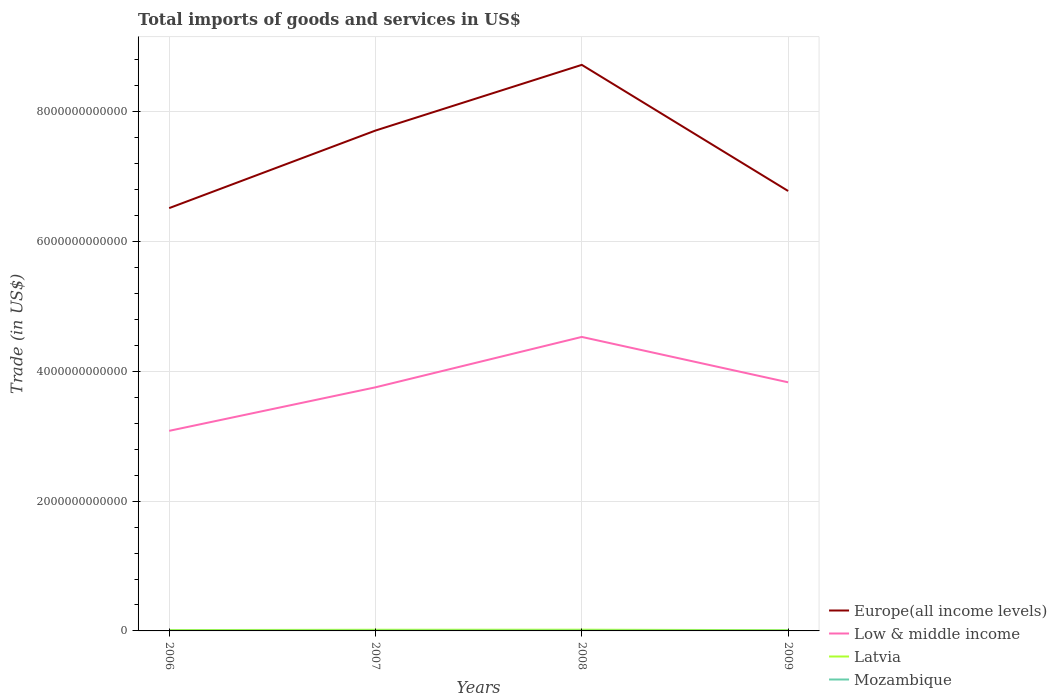How many different coloured lines are there?
Offer a terse response. 4. Does the line corresponding to Low & middle income intersect with the line corresponding to Latvia?
Make the answer very short. No. Across all years, what is the maximum total imports of goods and services in Mozambique?
Offer a very short reply. 3.41e+09. In which year was the total imports of goods and services in Latvia maximum?
Provide a short and direct response. 2009. What is the total total imports of goods and services in Low & middle income in the graph?
Your answer should be compact. -7.48e+11. What is the difference between the highest and the second highest total imports of goods and services in Latvia?
Make the answer very short. 7.10e+09. What is the difference between the highest and the lowest total imports of goods and services in Latvia?
Provide a short and direct response. 2. Is the total imports of goods and services in Mozambique strictly greater than the total imports of goods and services in Low & middle income over the years?
Provide a succinct answer. Yes. How many years are there in the graph?
Offer a terse response. 4. What is the difference between two consecutive major ticks on the Y-axis?
Offer a very short reply. 2.00e+12. Are the values on the major ticks of Y-axis written in scientific E-notation?
Offer a very short reply. No. How many legend labels are there?
Provide a short and direct response. 4. What is the title of the graph?
Ensure brevity in your answer.  Total imports of goods and services in US$. Does "Middle East & North Africa (all income levels)" appear as one of the legend labels in the graph?
Your answer should be very brief. No. What is the label or title of the X-axis?
Your answer should be very brief. Years. What is the label or title of the Y-axis?
Keep it short and to the point. Trade (in US$). What is the Trade (in US$) of Europe(all income levels) in 2006?
Your answer should be compact. 6.52e+12. What is the Trade (in US$) of Low & middle income in 2006?
Make the answer very short. 3.08e+12. What is the Trade (in US$) in Latvia in 2006?
Offer a very short reply. 1.30e+1. What is the Trade (in US$) in Mozambique in 2006?
Make the answer very short. 3.41e+09. What is the Trade (in US$) in Europe(all income levels) in 2007?
Keep it short and to the point. 7.71e+12. What is the Trade (in US$) of Low & middle income in 2007?
Your response must be concise. 3.75e+12. What is the Trade (in US$) of Latvia in 2007?
Ensure brevity in your answer.  1.78e+1. What is the Trade (in US$) of Mozambique in 2007?
Give a very brief answer. 3.74e+09. What is the Trade (in US$) of Europe(all income levels) in 2008?
Offer a terse response. 8.72e+12. What is the Trade (in US$) of Low & middle income in 2008?
Your answer should be very brief. 4.53e+12. What is the Trade (in US$) of Latvia in 2008?
Provide a short and direct response. 1.87e+1. What is the Trade (in US$) of Mozambique in 2008?
Provide a short and direct response. 4.17e+09. What is the Trade (in US$) in Europe(all income levels) in 2009?
Give a very brief answer. 6.78e+12. What is the Trade (in US$) of Low & middle income in 2009?
Your answer should be compact. 3.83e+12. What is the Trade (in US$) in Latvia in 2009?
Your response must be concise. 1.16e+1. What is the Trade (in US$) in Mozambique in 2009?
Give a very brief answer. 4.39e+09. Across all years, what is the maximum Trade (in US$) in Europe(all income levels)?
Provide a succinct answer. 8.72e+12. Across all years, what is the maximum Trade (in US$) in Low & middle income?
Keep it short and to the point. 4.53e+12. Across all years, what is the maximum Trade (in US$) of Latvia?
Ensure brevity in your answer.  1.87e+1. Across all years, what is the maximum Trade (in US$) of Mozambique?
Provide a short and direct response. 4.39e+09. Across all years, what is the minimum Trade (in US$) in Europe(all income levels)?
Provide a succinct answer. 6.52e+12. Across all years, what is the minimum Trade (in US$) of Low & middle income?
Ensure brevity in your answer.  3.08e+12. Across all years, what is the minimum Trade (in US$) of Latvia?
Your answer should be very brief. 1.16e+1. Across all years, what is the minimum Trade (in US$) of Mozambique?
Your response must be concise. 3.41e+09. What is the total Trade (in US$) of Europe(all income levels) in the graph?
Provide a short and direct response. 2.97e+13. What is the total Trade (in US$) in Low & middle income in the graph?
Keep it short and to the point. 1.52e+13. What is the total Trade (in US$) of Latvia in the graph?
Provide a succinct answer. 6.10e+1. What is the total Trade (in US$) in Mozambique in the graph?
Offer a very short reply. 1.57e+1. What is the difference between the Trade (in US$) in Europe(all income levels) in 2006 and that in 2007?
Offer a very short reply. -1.20e+12. What is the difference between the Trade (in US$) of Low & middle income in 2006 and that in 2007?
Provide a short and direct response. -6.71e+11. What is the difference between the Trade (in US$) of Latvia in 2006 and that in 2007?
Provide a short and direct response. -4.75e+09. What is the difference between the Trade (in US$) in Mozambique in 2006 and that in 2007?
Provide a succinct answer. -3.32e+08. What is the difference between the Trade (in US$) of Europe(all income levels) in 2006 and that in 2008?
Keep it short and to the point. -2.21e+12. What is the difference between the Trade (in US$) in Low & middle income in 2006 and that in 2008?
Your answer should be very brief. -1.45e+12. What is the difference between the Trade (in US$) in Latvia in 2006 and that in 2008?
Your answer should be compact. -5.67e+09. What is the difference between the Trade (in US$) in Mozambique in 2006 and that in 2008?
Ensure brevity in your answer.  -7.62e+08. What is the difference between the Trade (in US$) of Europe(all income levels) in 2006 and that in 2009?
Give a very brief answer. -2.64e+11. What is the difference between the Trade (in US$) of Low & middle income in 2006 and that in 2009?
Keep it short and to the point. -7.48e+11. What is the difference between the Trade (in US$) of Latvia in 2006 and that in 2009?
Give a very brief answer. 1.43e+09. What is the difference between the Trade (in US$) of Mozambique in 2006 and that in 2009?
Your response must be concise. -9.79e+08. What is the difference between the Trade (in US$) in Europe(all income levels) in 2007 and that in 2008?
Ensure brevity in your answer.  -1.01e+12. What is the difference between the Trade (in US$) of Low & middle income in 2007 and that in 2008?
Make the answer very short. -7.77e+11. What is the difference between the Trade (in US$) in Latvia in 2007 and that in 2008?
Offer a terse response. -9.14e+08. What is the difference between the Trade (in US$) of Mozambique in 2007 and that in 2008?
Provide a short and direct response. -4.30e+08. What is the difference between the Trade (in US$) of Europe(all income levels) in 2007 and that in 2009?
Give a very brief answer. 9.31e+11. What is the difference between the Trade (in US$) of Low & middle income in 2007 and that in 2009?
Your answer should be very brief. -7.73e+1. What is the difference between the Trade (in US$) in Latvia in 2007 and that in 2009?
Your answer should be very brief. 6.19e+09. What is the difference between the Trade (in US$) of Mozambique in 2007 and that in 2009?
Your response must be concise. -6.48e+08. What is the difference between the Trade (in US$) of Europe(all income levels) in 2008 and that in 2009?
Your answer should be compact. 1.94e+12. What is the difference between the Trade (in US$) in Low & middle income in 2008 and that in 2009?
Offer a very short reply. 6.99e+11. What is the difference between the Trade (in US$) of Latvia in 2008 and that in 2009?
Your response must be concise. 7.10e+09. What is the difference between the Trade (in US$) of Mozambique in 2008 and that in 2009?
Offer a very short reply. -2.17e+08. What is the difference between the Trade (in US$) in Europe(all income levels) in 2006 and the Trade (in US$) in Low & middle income in 2007?
Ensure brevity in your answer.  2.76e+12. What is the difference between the Trade (in US$) of Europe(all income levels) in 2006 and the Trade (in US$) of Latvia in 2007?
Make the answer very short. 6.50e+12. What is the difference between the Trade (in US$) in Europe(all income levels) in 2006 and the Trade (in US$) in Mozambique in 2007?
Provide a succinct answer. 6.51e+12. What is the difference between the Trade (in US$) of Low & middle income in 2006 and the Trade (in US$) of Latvia in 2007?
Provide a short and direct response. 3.07e+12. What is the difference between the Trade (in US$) in Low & middle income in 2006 and the Trade (in US$) in Mozambique in 2007?
Make the answer very short. 3.08e+12. What is the difference between the Trade (in US$) of Latvia in 2006 and the Trade (in US$) of Mozambique in 2007?
Give a very brief answer. 9.27e+09. What is the difference between the Trade (in US$) of Europe(all income levels) in 2006 and the Trade (in US$) of Low & middle income in 2008?
Offer a terse response. 1.99e+12. What is the difference between the Trade (in US$) of Europe(all income levels) in 2006 and the Trade (in US$) of Latvia in 2008?
Provide a short and direct response. 6.50e+12. What is the difference between the Trade (in US$) of Europe(all income levels) in 2006 and the Trade (in US$) of Mozambique in 2008?
Make the answer very short. 6.51e+12. What is the difference between the Trade (in US$) in Low & middle income in 2006 and the Trade (in US$) in Latvia in 2008?
Keep it short and to the point. 3.06e+12. What is the difference between the Trade (in US$) of Low & middle income in 2006 and the Trade (in US$) of Mozambique in 2008?
Give a very brief answer. 3.08e+12. What is the difference between the Trade (in US$) of Latvia in 2006 and the Trade (in US$) of Mozambique in 2008?
Provide a short and direct response. 8.84e+09. What is the difference between the Trade (in US$) in Europe(all income levels) in 2006 and the Trade (in US$) in Low & middle income in 2009?
Offer a very short reply. 2.68e+12. What is the difference between the Trade (in US$) of Europe(all income levels) in 2006 and the Trade (in US$) of Latvia in 2009?
Offer a terse response. 6.50e+12. What is the difference between the Trade (in US$) of Europe(all income levels) in 2006 and the Trade (in US$) of Mozambique in 2009?
Your answer should be compact. 6.51e+12. What is the difference between the Trade (in US$) in Low & middle income in 2006 and the Trade (in US$) in Latvia in 2009?
Give a very brief answer. 3.07e+12. What is the difference between the Trade (in US$) in Low & middle income in 2006 and the Trade (in US$) in Mozambique in 2009?
Ensure brevity in your answer.  3.08e+12. What is the difference between the Trade (in US$) of Latvia in 2006 and the Trade (in US$) of Mozambique in 2009?
Provide a short and direct response. 8.62e+09. What is the difference between the Trade (in US$) of Europe(all income levels) in 2007 and the Trade (in US$) of Low & middle income in 2008?
Offer a very short reply. 3.18e+12. What is the difference between the Trade (in US$) in Europe(all income levels) in 2007 and the Trade (in US$) in Latvia in 2008?
Give a very brief answer. 7.69e+12. What is the difference between the Trade (in US$) of Europe(all income levels) in 2007 and the Trade (in US$) of Mozambique in 2008?
Ensure brevity in your answer.  7.71e+12. What is the difference between the Trade (in US$) of Low & middle income in 2007 and the Trade (in US$) of Latvia in 2008?
Give a very brief answer. 3.73e+12. What is the difference between the Trade (in US$) of Low & middle income in 2007 and the Trade (in US$) of Mozambique in 2008?
Make the answer very short. 3.75e+12. What is the difference between the Trade (in US$) in Latvia in 2007 and the Trade (in US$) in Mozambique in 2008?
Make the answer very short. 1.36e+1. What is the difference between the Trade (in US$) in Europe(all income levels) in 2007 and the Trade (in US$) in Low & middle income in 2009?
Offer a very short reply. 3.88e+12. What is the difference between the Trade (in US$) in Europe(all income levels) in 2007 and the Trade (in US$) in Latvia in 2009?
Provide a short and direct response. 7.70e+12. What is the difference between the Trade (in US$) of Europe(all income levels) in 2007 and the Trade (in US$) of Mozambique in 2009?
Ensure brevity in your answer.  7.71e+12. What is the difference between the Trade (in US$) in Low & middle income in 2007 and the Trade (in US$) in Latvia in 2009?
Your answer should be very brief. 3.74e+12. What is the difference between the Trade (in US$) in Low & middle income in 2007 and the Trade (in US$) in Mozambique in 2009?
Provide a succinct answer. 3.75e+12. What is the difference between the Trade (in US$) of Latvia in 2007 and the Trade (in US$) of Mozambique in 2009?
Offer a very short reply. 1.34e+1. What is the difference between the Trade (in US$) in Europe(all income levels) in 2008 and the Trade (in US$) in Low & middle income in 2009?
Provide a succinct answer. 4.89e+12. What is the difference between the Trade (in US$) in Europe(all income levels) in 2008 and the Trade (in US$) in Latvia in 2009?
Your response must be concise. 8.71e+12. What is the difference between the Trade (in US$) in Europe(all income levels) in 2008 and the Trade (in US$) in Mozambique in 2009?
Ensure brevity in your answer.  8.72e+12. What is the difference between the Trade (in US$) in Low & middle income in 2008 and the Trade (in US$) in Latvia in 2009?
Keep it short and to the point. 4.52e+12. What is the difference between the Trade (in US$) of Low & middle income in 2008 and the Trade (in US$) of Mozambique in 2009?
Make the answer very short. 4.53e+12. What is the difference between the Trade (in US$) of Latvia in 2008 and the Trade (in US$) of Mozambique in 2009?
Provide a succinct answer. 1.43e+1. What is the average Trade (in US$) in Europe(all income levels) per year?
Give a very brief answer. 7.43e+12. What is the average Trade (in US$) of Low & middle income per year?
Keep it short and to the point. 3.80e+12. What is the average Trade (in US$) of Latvia per year?
Keep it short and to the point. 1.53e+1. What is the average Trade (in US$) of Mozambique per year?
Make the answer very short. 3.93e+09. In the year 2006, what is the difference between the Trade (in US$) of Europe(all income levels) and Trade (in US$) of Low & middle income?
Give a very brief answer. 3.43e+12. In the year 2006, what is the difference between the Trade (in US$) in Europe(all income levels) and Trade (in US$) in Latvia?
Offer a terse response. 6.50e+12. In the year 2006, what is the difference between the Trade (in US$) of Europe(all income levels) and Trade (in US$) of Mozambique?
Ensure brevity in your answer.  6.51e+12. In the year 2006, what is the difference between the Trade (in US$) in Low & middle income and Trade (in US$) in Latvia?
Provide a succinct answer. 3.07e+12. In the year 2006, what is the difference between the Trade (in US$) of Low & middle income and Trade (in US$) of Mozambique?
Offer a terse response. 3.08e+12. In the year 2006, what is the difference between the Trade (in US$) of Latvia and Trade (in US$) of Mozambique?
Make the answer very short. 9.60e+09. In the year 2007, what is the difference between the Trade (in US$) in Europe(all income levels) and Trade (in US$) in Low & middle income?
Offer a very short reply. 3.96e+12. In the year 2007, what is the difference between the Trade (in US$) of Europe(all income levels) and Trade (in US$) of Latvia?
Offer a terse response. 7.69e+12. In the year 2007, what is the difference between the Trade (in US$) of Europe(all income levels) and Trade (in US$) of Mozambique?
Ensure brevity in your answer.  7.71e+12. In the year 2007, what is the difference between the Trade (in US$) of Low & middle income and Trade (in US$) of Latvia?
Provide a succinct answer. 3.74e+12. In the year 2007, what is the difference between the Trade (in US$) of Low & middle income and Trade (in US$) of Mozambique?
Ensure brevity in your answer.  3.75e+12. In the year 2007, what is the difference between the Trade (in US$) in Latvia and Trade (in US$) in Mozambique?
Ensure brevity in your answer.  1.40e+1. In the year 2008, what is the difference between the Trade (in US$) of Europe(all income levels) and Trade (in US$) of Low & middle income?
Offer a terse response. 4.19e+12. In the year 2008, what is the difference between the Trade (in US$) in Europe(all income levels) and Trade (in US$) in Latvia?
Make the answer very short. 8.70e+12. In the year 2008, what is the difference between the Trade (in US$) of Europe(all income levels) and Trade (in US$) of Mozambique?
Offer a very short reply. 8.72e+12. In the year 2008, what is the difference between the Trade (in US$) of Low & middle income and Trade (in US$) of Latvia?
Your answer should be compact. 4.51e+12. In the year 2008, what is the difference between the Trade (in US$) in Low & middle income and Trade (in US$) in Mozambique?
Your answer should be compact. 4.53e+12. In the year 2008, what is the difference between the Trade (in US$) of Latvia and Trade (in US$) of Mozambique?
Keep it short and to the point. 1.45e+1. In the year 2009, what is the difference between the Trade (in US$) of Europe(all income levels) and Trade (in US$) of Low & middle income?
Your response must be concise. 2.95e+12. In the year 2009, what is the difference between the Trade (in US$) in Europe(all income levels) and Trade (in US$) in Latvia?
Provide a succinct answer. 6.77e+12. In the year 2009, what is the difference between the Trade (in US$) of Europe(all income levels) and Trade (in US$) of Mozambique?
Your answer should be very brief. 6.77e+12. In the year 2009, what is the difference between the Trade (in US$) in Low & middle income and Trade (in US$) in Latvia?
Provide a short and direct response. 3.82e+12. In the year 2009, what is the difference between the Trade (in US$) of Low & middle income and Trade (in US$) of Mozambique?
Ensure brevity in your answer.  3.83e+12. In the year 2009, what is the difference between the Trade (in US$) in Latvia and Trade (in US$) in Mozambique?
Provide a succinct answer. 7.19e+09. What is the ratio of the Trade (in US$) in Europe(all income levels) in 2006 to that in 2007?
Provide a succinct answer. 0.84. What is the ratio of the Trade (in US$) of Low & middle income in 2006 to that in 2007?
Your answer should be compact. 0.82. What is the ratio of the Trade (in US$) of Latvia in 2006 to that in 2007?
Make the answer very short. 0.73. What is the ratio of the Trade (in US$) of Mozambique in 2006 to that in 2007?
Your response must be concise. 0.91. What is the ratio of the Trade (in US$) in Europe(all income levels) in 2006 to that in 2008?
Your response must be concise. 0.75. What is the ratio of the Trade (in US$) in Low & middle income in 2006 to that in 2008?
Provide a short and direct response. 0.68. What is the ratio of the Trade (in US$) of Latvia in 2006 to that in 2008?
Give a very brief answer. 0.7. What is the ratio of the Trade (in US$) in Mozambique in 2006 to that in 2008?
Your response must be concise. 0.82. What is the ratio of the Trade (in US$) in Europe(all income levels) in 2006 to that in 2009?
Offer a terse response. 0.96. What is the ratio of the Trade (in US$) of Low & middle income in 2006 to that in 2009?
Provide a short and direct response. 0.8. What is the ratio of the Trade (in US$) in Latvia in 2006 to that in 2009?
Offer a terse response. 1.12. What is the ratio of the Trade (in US$) of Mozambique in 2006 to that in 2009?
Make the answer very short. 0.78. What is the ratio of the Trade (in US$) in Europe(all income levels) in 2007 to that in 2008?
Ensure brevity in your answer.  0.88. What is the ratio of the Trade (in US$) in Low & middle income in 2007 to that in 2008?
Offer a terse response. 0.83. What is the ratio of the Trade (in US$) in Latvia in 2007 to that in 2008?
Offer a terse response. 0.95. What is the ratio of the Trade (in US$) in Mozambique in 2007 to that in 2008?
Make the answer very short. 0.9. What is the ratio of the Trade (in US$) in Europe(all income levels) in 2007 to that in 2009?
Give a very brief answer. 1.14. What is the ratio of the Trade (in US$) of Low & middle income in 2007 to that in 2009?
Make the answer very short. 0.98. What is the ratio of the Trade (in US$) of Latvia in 2007 to that in 2009?
Ensure brevity in your answer.  1.53. What is the ratio of the Trade (in US$) in Mozambique in 2007 to that in 2009?
Your answer should be very brief. 0.85. What is the ratio of the Trade (in US$) of Europe(all income levels) in 2008 to that in 2009?
Offer a terse response. 1.29. What is the ratio of the Trade (in US$) of Low & middle income in 2008 to that in 2009?
Give a very brief answer. 1.18. What is the ratio of the Trade (in US$) in Latvia in 2008 to that in 2009?
Keep it short and to the point. 1.61. What is the ratio of the Trade (in US$) of Mozambique in 2008 to that in 2009?
Your response must be concise. 0.95. What is the difference between the highest and the second highest Trade (in US$) of Europe(all income levels)?
Offer a terse response. 1.01e+12. What is the difference between the highest and the second highest Trade (in US$) of Low & middle income?
Your answer should be compact. 6.99e+11. What is the difference between the highest and the second highest Trade (in US$) in Latvia?
Ensure brevity in your answer.  9.14e+08. What is the difference between the highest and the second highest Trade (in US$) of Mozambique?
Give a very brief answer. 2.17e+08. What is the difference between the highest and the lowest Trade (in US$) of Europe(all income levels)?
Give a very brief answer. 2.21e+12. What is the difference between the highest and the lowest Trade (in US$) of Low & middle income?
Offer a terse response. 1.45e+12. What is the difference between the highest and the lowest Trade (in US$) in Latvia?
Provide a succinct answer. 7.10e+09. What is the difference between the highest and the lowest Trade (in US$) in Mozambique?
Ensure brevity in your answer.  9.79e+08. 